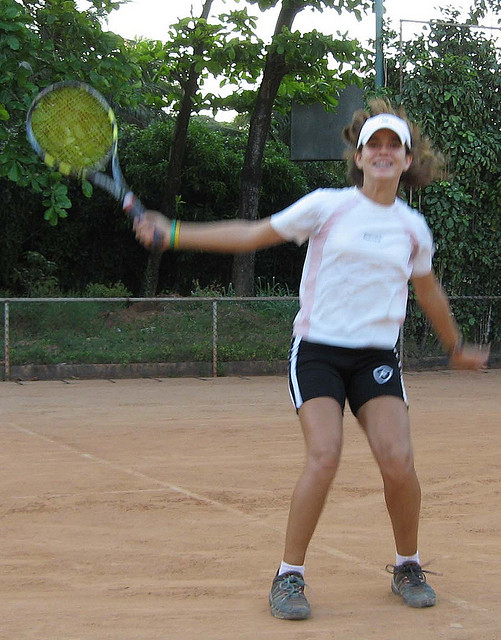<image>What logo is on the women's shorts? I'm not sure what logo is on the women's shorts. It could be Croc, Nike, Raiders, Diamond, Ping, Adidas, or an unknown brand. What logo is on the women's shorts? I am not sure what logo is on the women's shorts. It can be seen 'croc', 'nike', 'raiders', 'diamond', 'ping', 'adidas', 'circle', 'shield' or an unknown brand. 